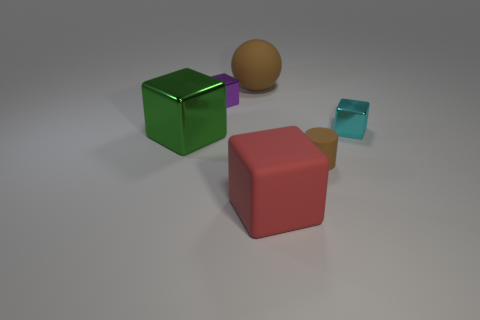Is the size of the green shiny object the same as the brown thing that is behind the green metal thing?
Provide a succinct answer. Yes. Are there fewer green things behind the rubber sphere than red cubes on the right side of the small rubber cylinder?
Provide a succinct answer. No. How big is the cyan thing that is in front of the purple cube?
Ensure brevity in your answer.  Small. Is the size of the purple cube the same as the cyan metallic cube?
Keep it short and to the point. Yes. What number of big blocks are both right of the large green object and to the left of the matte sphere?
Keep it short and to the point. 0. How many cyan things are either large matte objects or balls?
Keep it short and to the point. 0. How many shiny objects are small cyan cubes or large green objects?
Keep it short and to the point. 2. Are there any tiny brown cylinders?
Keep it short and to the point. Yes. Do the tiny purple object and the red matte object have the same shape?
Your answer should be very brief. Yes. There is a big cube that is on the left side of the block in front of the green shiny thing; how many large brown rubber things are on the left side of it?
Keep it short and to the point. 0. 